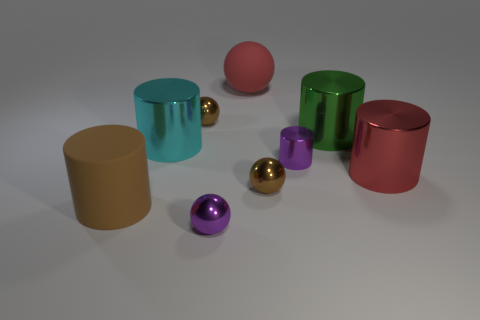Do the metallic sphere that is behind the large red cylinder and the large matte thing that is behind the red cylinder have the same color?
Ensure brevity in your answer.  No. There is another small thing that is the same shape as the cyan object; what color is it?
Offer a terse response. Purple. What is the material of the tiny ball that is both in front of the small cylinder and behind the tiny purple ball?
Keep it short and to the point. Metal. Are the cylinder that is in front of the large red shiny object and the red thing that is to the right of the big red matte sphere made of the same material?
Provide a short and direct response. No. There is a brown rubber object that is the same shape as the large cyan shiny thing; what is its size?
Your answer should be very brief. Large. What color is the matte thing that is in front of the small brown metal ball that is behind the red cylinder?
Offer a very short reply. Brown. Is there anything else that is the same shape as the large red matte thing?
Your response must be concise. Yes. Are there the same number of large metal things that are on the left side of the large red sphere and small balls in front of the large cyan metallic thing?
Give a very brief answer. No. What shape is the large matte thing that is behind the big brown matte cylinder?
Provide a succinct answer. Sphere. What material is the tiny purple object left of the large red matte sphere behind the red metallic object?
Ensure brevity in your answer.  Metal. 